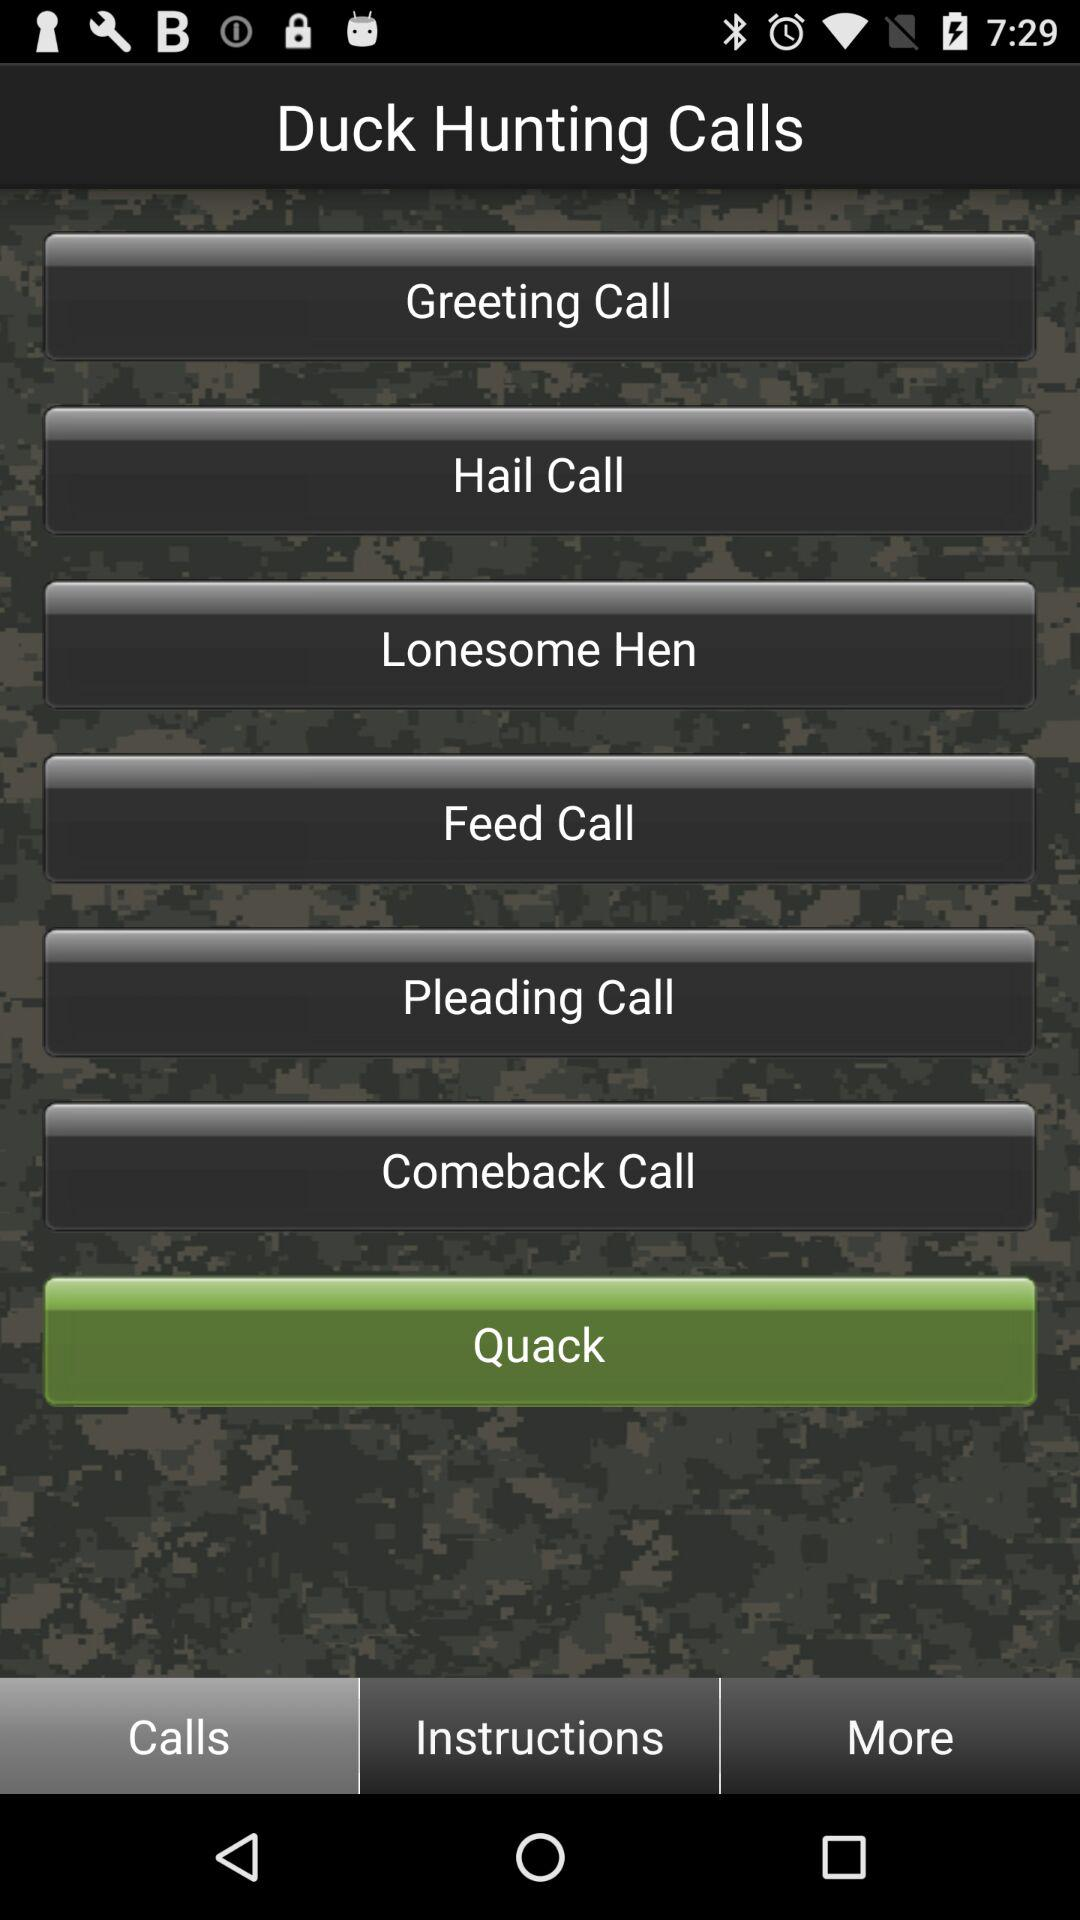What are the different available "Duck Hunting Calls"? The different available duck hunting calls are "Greeting Call", "Hail Call", "Lonesome Hen", "Feed Call", "Pleading Call", "Comeback Call" and "Quack". 